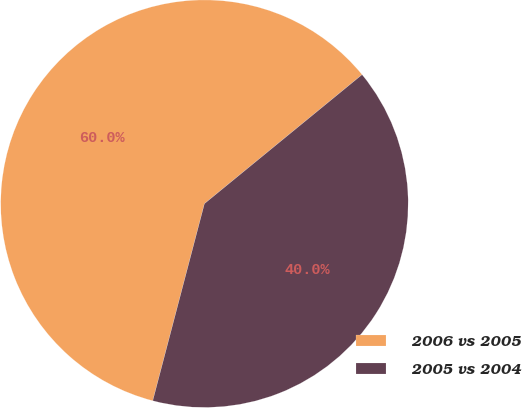<chart> <loc_0><loc_0><loc_500><loc_500><pie_chart><fcel>2006 vs 2005<fcel>2005 vs 2004<nl><fcel>60.0%<fcel>40.0%<nl></chart> 